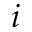Convert formula to latex. <formula><loc_0><loc_0><loc_500><loc_500>i</formula> 